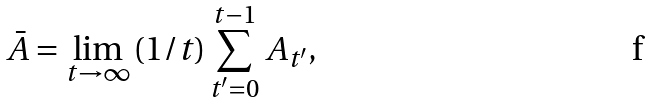<formula> <loc_0><loc_0><loc_500><loc_500>\bar { A } = \lim _ { t \to \infty } { ( 1 / t ) \sum _ { t ^ { \prime } = 0 } ^ { t - 1 } { A _ { t ^ { \prime } } } } ,</formula> 